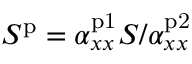Convert formula to latex. <formula><loc_0><loc_0><loc_500><loc_500>S ^ { p } = \alpha _ { x x } ^ { p 1 } S / \alpha _ { x x } ^ { p 2 }</formula> 